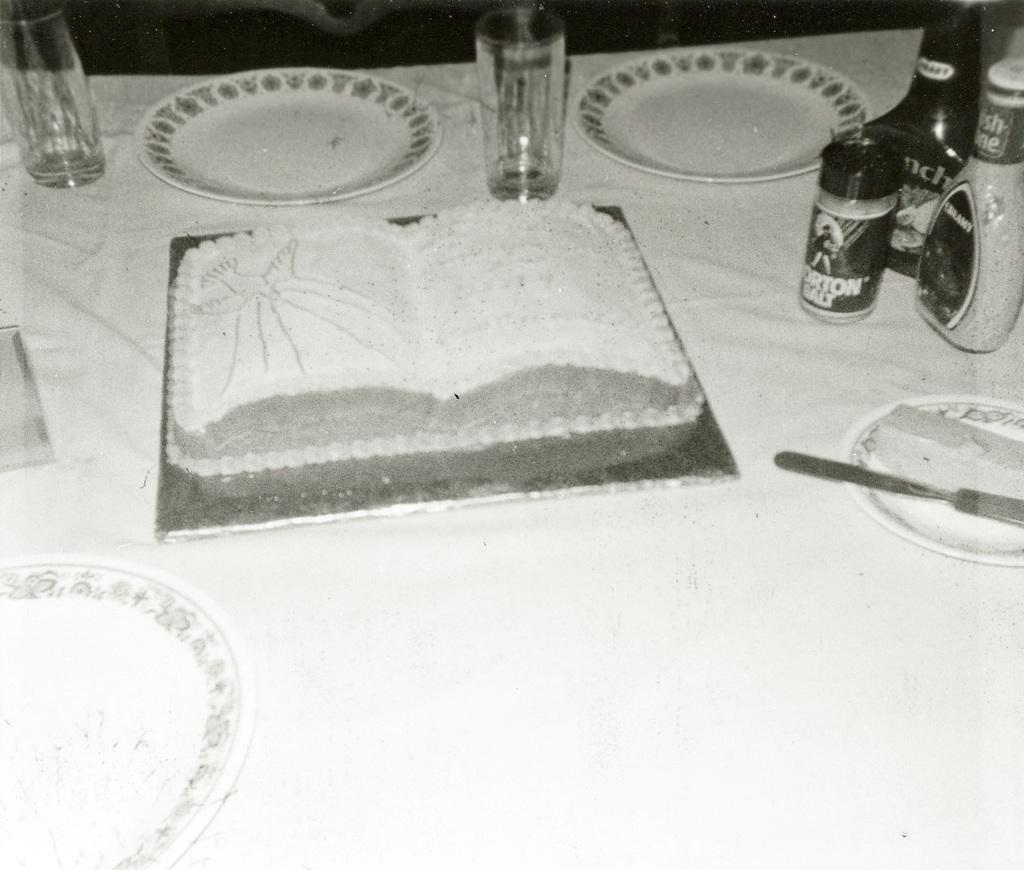What type of dishware can be seen in the image? There are plates and glasses in the image. What other objects are present in the image? There are other objects in the image, but their specific details are not mentioned in the provided facts. On what surface are the objects placed? The objects are placed on a white surface. What size are the teeth of the person in the image? There is no person present in the image, so their teeth size cannot be determined. 